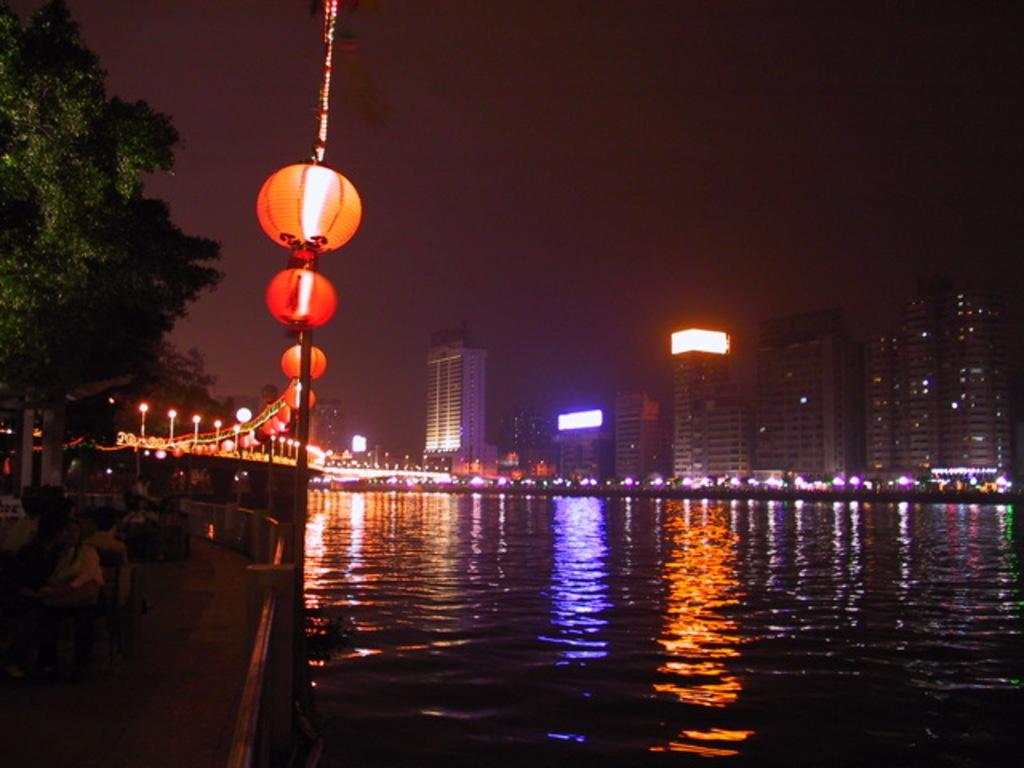Could you give a brief overview of what you see in this image? In the center of the image we can see the sky, buildings, lights, water, trees, lanterns, few people and a few other objects. 